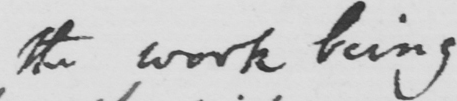What is written in this line of handwriting? the work being 